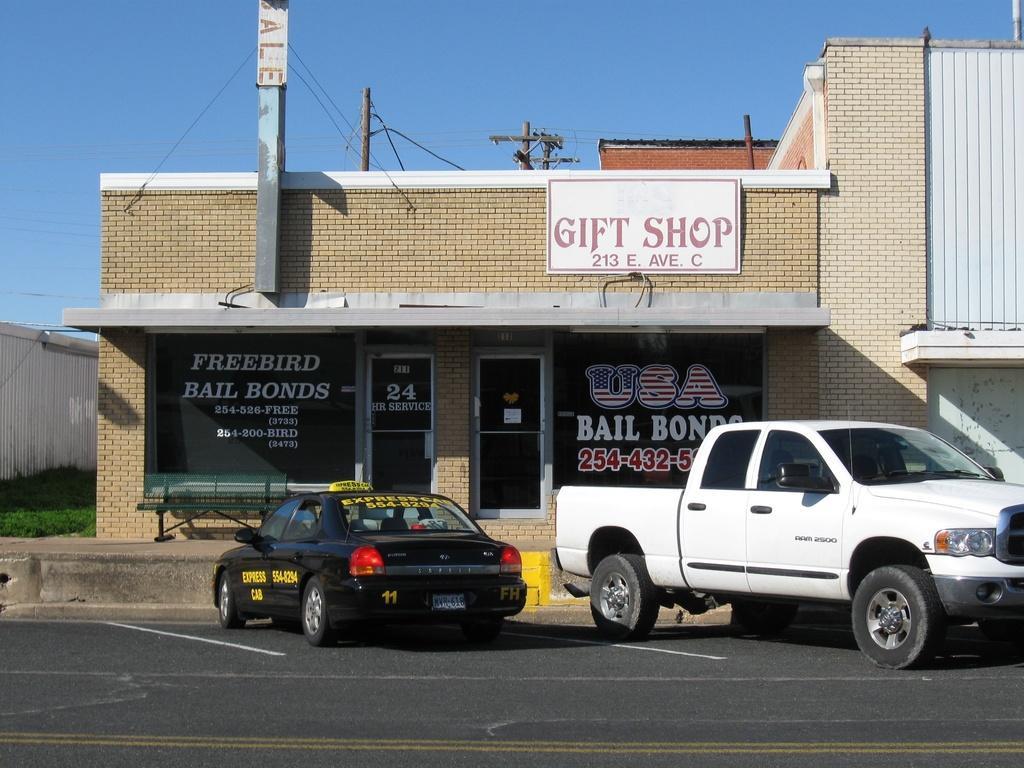Could you give a brief overview of what you see in this image? In this image there are two cars parked on the road in front of a shop, behind the shop there are electrical poles with cables on it, beside the shop there is grass and a wooden fence. 